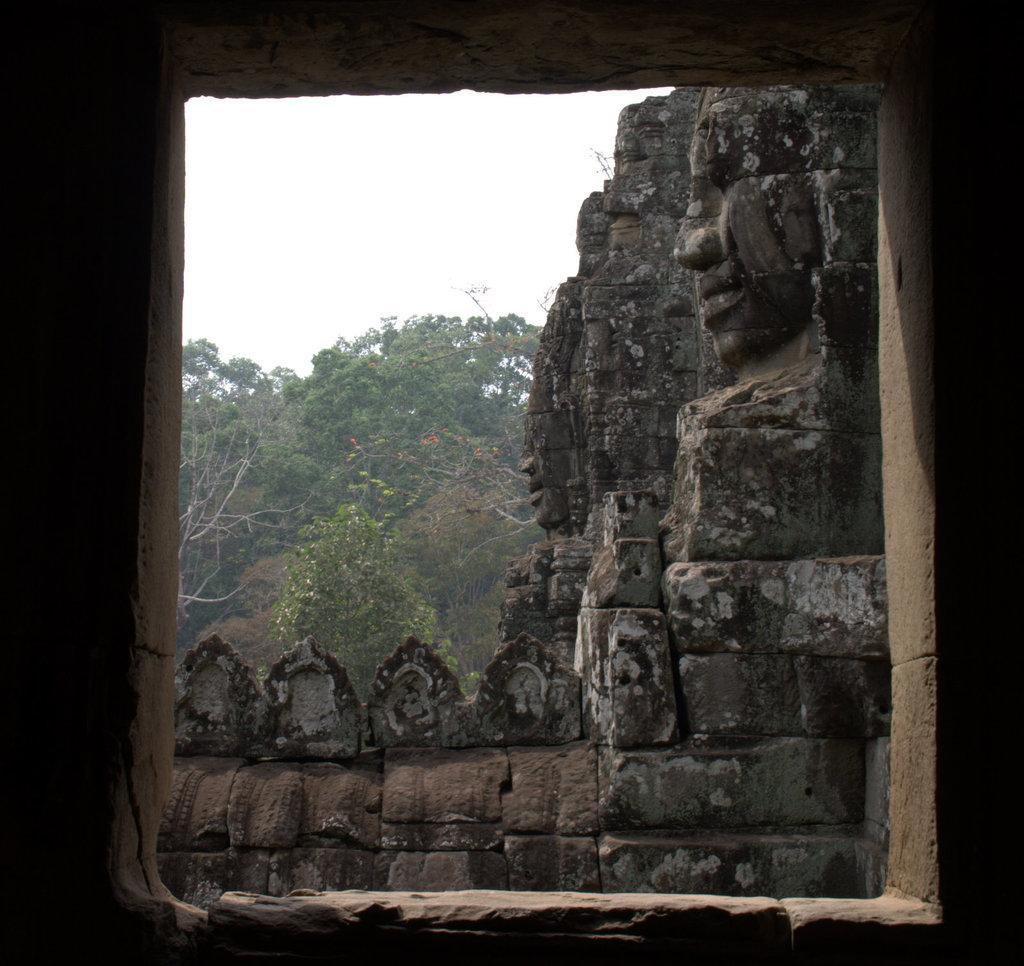Please provide a concise description of this image. In front of the picture, we see an open window which is made up of rocks. From the window, we can see the rocks which are carved and trees. At the top of the picture, we see the sky. 